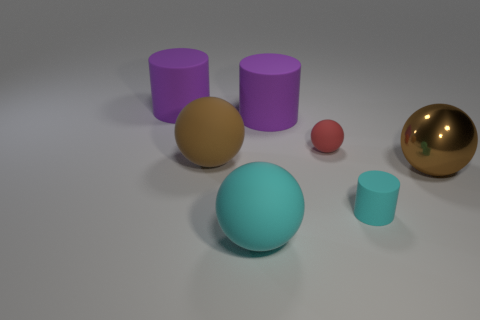What number of tiny things are cyan rubber balls or yellow cubes?
Keep it short and to the point. 0. What is the size of the ball that is in front of the brown rubber thing and to the left of the big brown metallic ball?
Provide a short and direct response. Large. How many large spheres are to the right of the big shiny ball?
Ensure brevity in your answer.  0. The rubber thing that is on the left side of the small cyan cylinder and in front of the shiny sphere has what shape?
Your response must be concise. Sphere. There is a ball that is the same color as the small cylinder; what is its material?
Give a very brief answer. Rubber. What number of spheres are either large green shiny things or large brown metallic things?
Your response must be concise. 1. There is a matte object that is the same color as the big shiny ball; what size is it?
Your response must be concise. Large. Is the number of small things left of the brown metal ball less than the number of large blue blocks?
Your response must be concise. No. There is a big ball that is on the left side of the small cylinder and behind the big cyan matte sphere; what is its color?
Offer a terse response. Brown. How many other things are the same shape as the tiny red rubber object?
Your response must be concise. 3. 